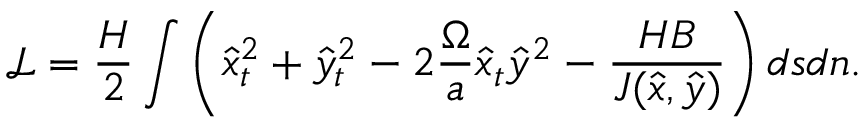Convert formula to latex. <formula><loc_0><loc_0><loc_500><loc_500>\mathcal { L } = \frac { H } { 2 } \int \left ( \hat { x } _ { t } ^ { 2 } + \hat { y } _ { t } ^ { 2 } - 2 \frac { \Omega } { a } \hat { x } _ { t } \hat { y } ^ { 2 } - \frac { H B } { J ( \hat { x } , \hat { y } ) } \right ) d s d n .</formula> 